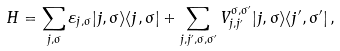Convert formula to latex. <formula><loc_0><loc_0><loc_500><loc_500>H = \sum _ { j , \sigma } \varepsilon _ { j , \sigma } | j , \sigma \rangle \langle j , \sigma | + \sum _ { j , j ^ { \prime } , \sigma , \sigma ^ { \prime } } V _ { j , j ^ { \prime } } ^ { \sigma , \sigma ^ { \prime } } | j , \sigma \rangle \langle j ^ { \prime } , \sigma ^ { \prime } | \, ,</formula> 